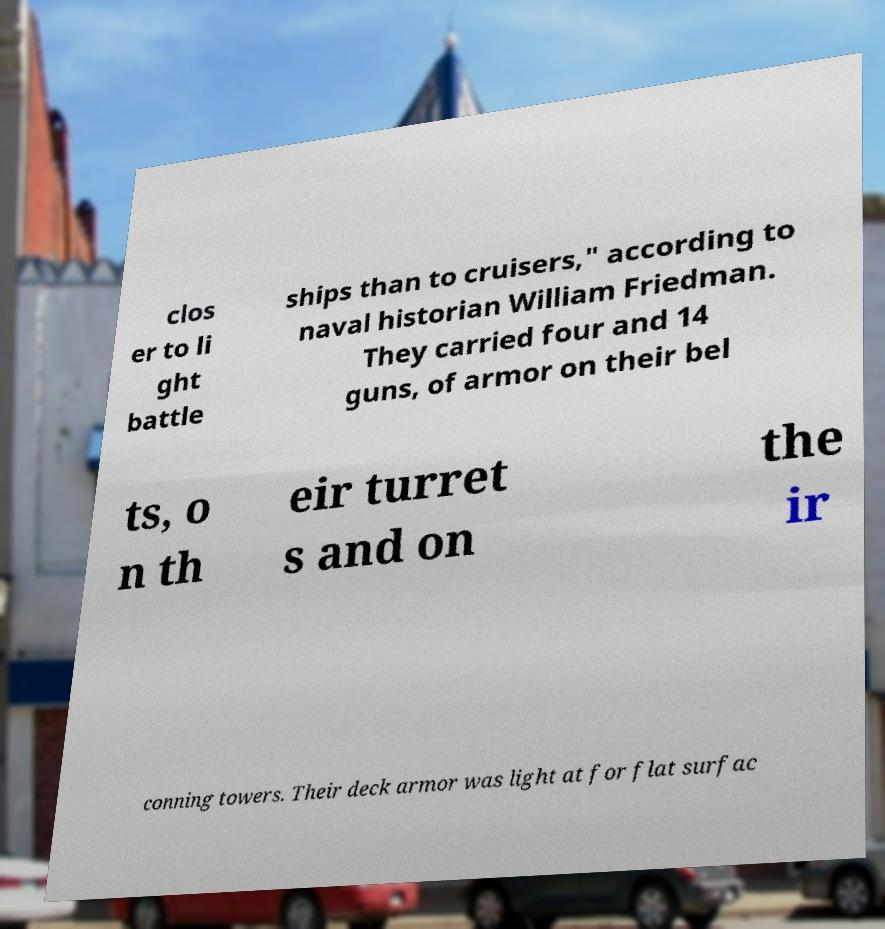For documentation purposes, I need the text within this image transcribed. Could you provide that? clos er to li ght battle ships than to cruisers," according to naval historian William Friedman. They carried four and 14 guns, of armor on their bel ts, o n th eir turret s and on the ir conning towers. Their deck armor was light at for flat surfac 